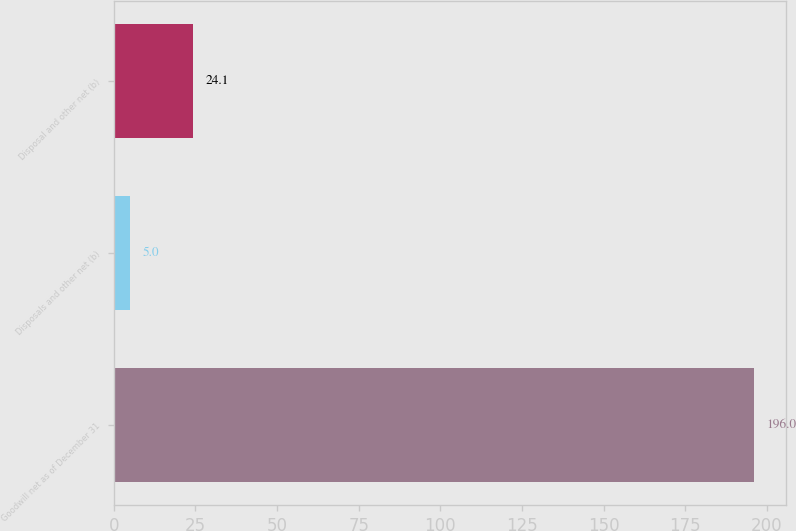<chart> <loc_0><loc_0><loc_500><loc_500><bar_chart><fcel>Goodwill net as of December 31<fcel>Disposals and other net (b)<fcel>Disposal and other net (b)<nl><fcel>196<fcel>5<fcel>24.1<nl></chart> 